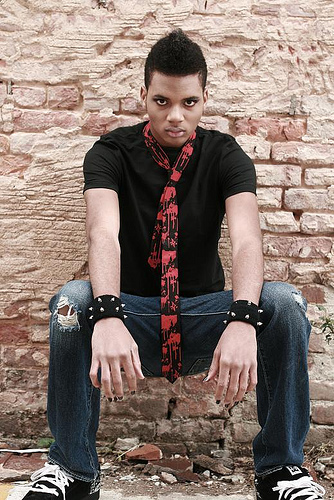How many people are in the picture? There is one person in the picture. He appears to be a young man sitting casually with a thoughtful expression, dressed in a black shirt with decorative bracelets on his wrists. 